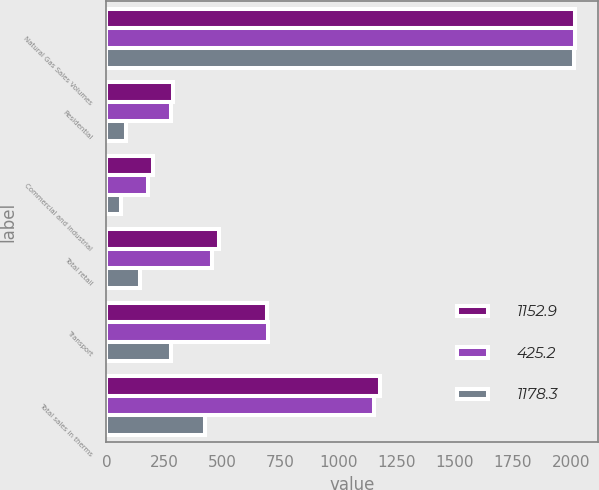Convert chart to OTSL. <chart><loc_0><loc_0><loc_500><loc_500><stacked_bar_chart><ecel><fcel>Natural Gas Sales Volumes<fcel>Residential<fcel>Commercial and industrial<fcel>Total retail<fcel>Transport<fcel>Total sales in therms<nl><fcel>1152.9<fcel>2017<fcel>285.6<fcel>199.4<fcel>485<fcel>693.3<fcel>1178.3<nl><fcel>425.2<fcel>2016<fcel>278.5<fcel>178.2<fcel>456.7<fcel>696.2<fcel>1152.9<nl><fcel>1178.3<fcel>2015<fcel>84.7<fcel>60.9<fcel>145.6<fcel>279.6<fcel>425.2<nl></chart> 